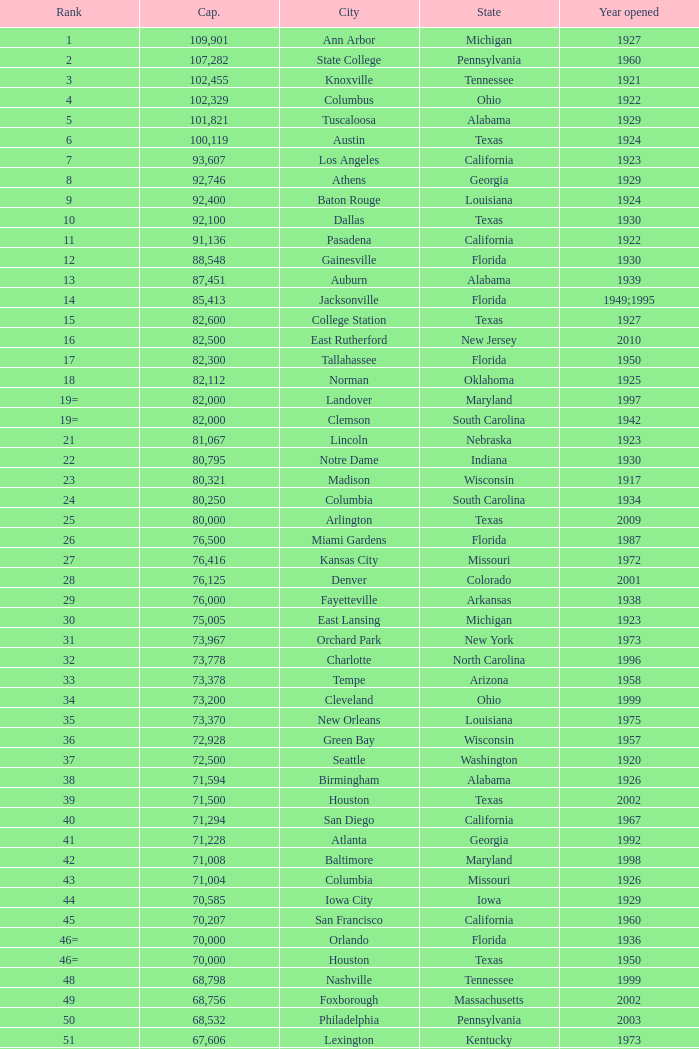Could you parse the entire table? {'header': ['Rank', 'Cap.', 'City', 'State', 'Year opened'], 'rows': [['1', '109,901', 'Ann Arbor', 'Michigan', '1927'], ['2', '107,282', 'State College', 'Pennsylvania', '1960'], ['3', '102,455', 'Knoxville', 'Tennessee', '1921'], ['4', '102,329', 'Columbus', 'Ohio', '1922'], ['5', '101,821', 'Tuscaloosa', 'Alabama', '1929'], ['6', '100,119', 'Austin', 'Texas', '1924'], ['7', '93,607', 'Los Angeles', 'California', '1923'], ['8', '92,746', 'Athens', 'Georgia', '1929'], ['9', '92,400', 'Baton Rouge', 'Louisiana', '1924'], ['10', '92,100', 'Dallas', 'Texas', '1930'], ['11', '91,136', 'Pasadena', 'California', '1922'], ['12', '88,548', 'Gainesville', 'Florida', '1930'], ['13', '87,451', 'Auburn', 'Alabama', '1939'], ['14', '85,413', 'Jacksonville', 'Florida', '1949;1995'], ['15', '82,600', 'College Station', 'Texas', '1927'], ['16', '82,500', 'East Rutherford', 'New Jersey', '2010'], ['17', '82,300', 'Tallahassee', 'Florida', '1950'], ['18', '82,112', 'Norman', 'Oklahoma', '1925'], ['19=', '82,000', 'Landover', 'Maryland', '1997'], ['19=', '82,000', 'Clemson', 'South Carolina', '1942'], ['21', '81,067', 'Lincoln', 'Nebraska', '1923'], ['22', '80,795', 'Notre Dame', 'Indiana', '1930'], ['23', '80,321', 'Madison', 'Wisconsin', '1917'], ['24', '80,250', 'Columbia', 'South Carolina', '1934'], ['25', '80,000', 'Arlington', 'Texas', '2009'], ['26', '76,500', 'Miami Gardens', 'Florida', '1987'], ['27', '76,416', 'Kansas City', 'Missouri', '1972'], ['28', '76,125', 'Denver', 'Colorado', '2001'], ['29', '76,000', 'Fayetteville', 'Arkansas', '1938'], ['30', '75,005', 'East Lansing', 'Michigan', '1923'], ['31', '73,967', 'Orchard Park', 'New York', '1973'], ['32', '73,778', 'Charlotte', 'North Carolina', '1996'], ['33', '73,378', 'Tempe', 'Arizona', '1958'], ['34', '73,200', 'Cleveland', 'Ohio', '1999'], ['35', '73,370', 'New Orleans', 'Louisiana', '1975'], ['36', '72,928', 'Green Bay', 'Wisconsin', '1957'], ['37', '72,500', 'Seattle', 'Washington', '1920'], ['38', '71,594', 'Birmingham', 'Alabama', '1926'], ['39', '71,500', 'Houston', 'Texas', '2002'], ['40', '71,294', 'San Diego', 'California', '1967'], ['41', '71,228', 'Atlanta', 'Georgia', '1992'], ['42', '71,008', 'Baltimore', 'Maryland', '1998'], ['43', '71,004', 'Columbia', 'Missouri', '1926'], ['44', '70,585', 'Iowa City', 'Iowa', '1929'], ['45', '70,207', 'San Francisco', 'California', '1960'], ['46=', '70,000', 'Orlando', 'Florida', '1936'], ['46=', '70,000', 'Houston', 'Texas', '1950'], ['48', '68,798', 'Nashville', 'Tennessee', '1999'], ['49', '68,756', 'Foxborough', 'Massachusetts', '2002'], ['50', '68,532', 'Philadelphia', 'Pennsylvania', '2003'], ['51', '67,606', 'Lexington', 'Kentucky', '1973'], ['52', '67,000', 'Seattle', 'Washington', '2002'], ['53', '66,965', 'St. Louis', 'Missouri', '1995'], ['54', '66,233', 'Blacksburg', 'Virginia', '1965'], ['55', '65,857', 'Tampa', 'Florida', '1998'], ['56', '65,790', 'Cincinnati', 'Ohio', '2000'], ['57', '65,050', 'Pittsburgh', 'Pennsylvania', '2001'], ['58=', '65,000', 'San Antonio', 'Texas', '1993'], ['58=', '65,000', 'Detroit', 'Michigan', '2002'], ['60', '64,269', 'New Haven', 'Connecticut', '1914'], ['61', '64,111', 'Minneapolis', 'Minnesota', '1982'], ['62', '64,045', 'Provo', 'Utah', '1964'], ['63', '63,400', 'Glendale', 'Arizona', '2006'], ['64', '63,026', 'Oakland', 'California', '1966'], ['65', '63,000', 'Indianapolis', 'Indiana', '2008'], ['65', '63.000', 'Chapel Hill', 'North Carolina', '1926'], ['66', '62,872', 'Champaign', 'Illinois', '1923'], ['67', '62,717', 'Berkeley', 'California', '1923'], ['68', '61,500', 'Chicago', 'Illinois', '1924;2003'], ['69', '62,500', 'West Lafayette', 'Indiana', '1924'], ['70', '62,380', 'Memphis', 'Tennessee', '1965'], ['71', '61,500', 'Charlottesville', 'Virginia', '1931'], ['72', '61,000', 'Lubbock', 'Texas', '1947'], ['73', '60,580', 'Oxford', 'Mississippi', '1915'], ['74', '60,540', 'Morgantown', 'West Virginia', '1980'], ['75', '60,492', 'Jackson', 'Mississippi', '1941'], ['76', '60,000', 'Stillwater', 'Oklahoma', '1920'], ['78', '57,803', 'Tucson', 'Arizona', '1928'], ['79', '57,583', 'Raleigh', 'North Carolina', '1966'], ['80', '56,692', 'Washington, D.C.', 'District of Columbia', '1961'], ['81=', '56,000', 'Los Angeles', 'California', '1962'], ['81=', '56,000', 'Louisville', 'Kentucky', '1998'], ['83', '55,082', 'Starkville', 'Mississippi', '1914'], ['84=', '55,000', 'Atlanta', 'Georgia', '1913'], ['84=', '55,000', 'Ames', 'Iowa', '1975'], ['86', '53,800', 'Eugene', 'Oregon', '1967'], ['87', '53,750', 'Boulder', 'Colorado', '1924'], ['88', '53,727', 'Little Rock', 'Arkansas', '1948'], ['89', '53,500', 'Bloomington', 'Indiana', '1960'], ['90', '52,593', 'Philadelphia', 'Pennsylvania', '1895'], ['91', '52,480', 'Colorado Springs', 'Colorado', '1962'], ['92', '52,454', 'Piscataway', 'New Jersey', '1994'], ['93', '52,200', 'Manhattan', 'Kansas', '1968'], ['94=', '51,500', 'College Park', 'Maryland', '1950'], ['94=', '51,500', 'El Paso', 'Texas', '1963'], ['96', '50,832', 'Shreveport', 'Louisiana', '1925'], ['97', '50,805', 'Minneapolis', 'Minnesota', '2009'], ['98', '50,445', 'Denver', 'Colorado', '1995'], ['99', '50,291', 'Bronx', 'New York', '2009'], ['100', '50,096', 'Atlanta', 'Georgia', '1996'], ['101', '50,071', 'Lawrence', 'Kansas', '1921'], ['102=', '50,000', 'Honolulu', 'Hawai ʻ i', '1975'], ['102=', '50,000', 'Greenville', 'North Carolina', '1963'], ['102=', '50,000', 'Waco', 'Texas', '1950'], ['102=', '50,000', 'Stanford', 'California', '1921;2006'], ['106', '49,262', 'Syracuse', 'New York', '1980'], ['107', '49,115', 'Arlington', 'Texas', '1994'], ['108', '49,033', 'Phoenix', 'Arizona', '1998'], ['109', '48,876', 'Baltimore', 'Maryland', '1992'], ['110', '47,130', 'Evanston', 'Illinois', '1996'], ['111', '47,116', 'Seattle', 'Washington', '1999'], ['112', '46,861', 'St. Louis', 'Missouri', '2006'], ['113', '45,674', 'Corvallis', 'Oregon', '1953'], ['114', '45,634', 'Salt Lake City', 'Utah', '1998'], ['115', '45,301', 'Orlando', 'Florida', '2007'], ['116', '45,050', 'Anaheim', 'California', '1966'], ['117', '44,500', 'Chestnut Hill', 'Massachusetts', '1957'], ['118', '44,008', 'Fort Worth', 'Texas', '1930'], ['119', '43,647', 'Philadelphia', 'Pennsylvania', '2004'], ['120', '43,545', 'Cleveland', 'Ohio', '1994'], ['121', '42,445', 'San Diego', 'California', '2004'], ['122', '42,059', 'Cincinnati', 'Ohio', '2003'], ['123', '41,900', 'Milwaukee', 'Wisconsin', '2001'], ['124', '41,888', 'Washington, D.C.', 'District of Columbia', '2008'], ['125', '41,800', 'Flushing, New York', 'New York', '2009'], ['126', '41,782', 'Detroit', 'Michigan', '2000'], ['127', '41,503', 'San Francisco', 'California', '2000'], ['128', '41,160', 'Chicago', 'Illinois', '1914'], ['129', '41,031', 'Fresno', 'California', '1980'], ['130', '40,950', 'Houston', 'Texas', '2000'], ['131', '40,646', 'Mobile', 'Alabama', '1948'], ['132', '40,615', 'Chicago', 'Illinois', '1991'], ['133', '40,094', 'Albuquerque', 'New Mexico', '1960'], ['134=', '40,000', 'South Williamsport', 'Pennsylvania', '1959'], ['134=', '40,000', 'East Hartford', 'Connecticut', '2003'], ['134=', '40,000', 'West Point', 'New York', '1924'], ['137', '39,790', 'Nashville', 'Tennessee', '1922'], ['138', '39,504', 'Minneapolis', 'Minnesota', '2010'], ['139', '39,000', 'Kansas City', 'Missouri', '1973'], ['140', '38,496', 'Pittsburgh', 'Pennsylvania', '2001'], ['141', '38,019', 'Huntington', 'West Virginia', '1991'], ['142', '37,402', 'Boston', 'Massachusetts', '1912'], ['143=', '37,000', 'Boise', 'Idaho', '1970'], ['143=', '37,000', 'Miami', 'Florida', '2012'], ['145', '36,973', 'St. Petersburg', 'Florida', '1990'], ['146', '36,800', 'Whitney', 'Nevada', '1971'], ['147', '36,000', 'Hattiesburg', 'Mississippi', '1932'], ['148', '35,117', 'Pullman', 'Washington', '1972'], ['149', '35,097', 'Cincinnati', 'Ohio', '1924'], ['150', '34,400', 'Fort Collins', 'Colorado', '1968'], ['151', '34,000', 'Annapolis', 'Maryland', '1959'], ['152', '33,941', 'Durham', 'North Carolina', '1929'], ['153', '32,580', 'Laramie', 'Wyoming', '1950'], ['154=', '32,000', 'University Park', 'Texas', '2000'], ['154=', '32,000', 'Houston', 'Texas', '1942'], ['156', '31,500', 'Winston-Salem', 'North Carolina', '1968'], ['157=', '31,000', 'Lafayette', 'Louisiana', '1971'], ['157=', '31,000', 'Akron', 'Ohio', '1940'], ['157=', '31,000', 'DeKalb', 'Illinois', '1965'], ['160', '30,964', 'Jonesboro', 'Arkansas', '1974'], ['161', '30,850', 'Denton', 'Texas', '2011'], ['162', '30,600', 'Ruston', 'Louisiana', '1960'], ['163', '30,456', 'San Jose', 'California', '1933'], ['164', '30,427', 'Monroe', 'Louisiana', '1978'], ['165', '30,343', 'Las Cruces', 'New Mexico', '1978'], ['166', '30,323', 'Allston', 'Massachusetts', '1903'], ['167', '30,295', 'Mount Pleasant', 'Michigan', '1972'], ['168=', '30,200', 'Ypsilanti', 'Michigan', '1969'], ['168=', '30,200', 'Kalamazoo', 'Michigan', '1939'], ['168=', '30,000', 'Boca Raton', 'Florida', '2011'], ['168=', '30,000', 'San Marcos', 'Texas', '1981'], ['168=', '30,000', 'Tulsa', 'Oklahoma', '1930'], ['168=', '30,000', 'Akron', 'Ohio', '2009'], ['168=', '30,000', 'Troy', 'Alabama', '1950'], ['168=', '30,000', 'Norfolk', 'Virginia', '1997'], ['176', '29,993', 'Reno', 'Nevada', '1966'], ['177', '29,013', 'Amherst', 'New York', '1993'], ['178', '29,000', 'Baton Rouge', 'Louisiana', '1928'], ['179', '28,646', 'Spokane', 'Washington', '1950'], ['180', '27,800', 'Princeton', 'New Jersey', '1998'], ['181', '27,000', 'Carson', 'California', '2003'], ['182', '26,248', 'Toledo', 'Ohio', '1937'], ['183', '25,600', 'Grambling', 'Louisiana', '1983'], ['184', '25,597', 'Ithaca', 'New York', '1915'], ['185', '25,500', 'Tallahassee', 'Florida', '1957'], ['186', '25,400', 'Muncie', 'Indiana', '1967'], ['187', '25,200', 'Missoula', 'Montana', '1986'], ['188', '25,189', 'Harrison', 'New Jersey', '2010'], ['189', '25,000', 'Kent', 'Ohio', '1969'], ['190', '24,877', 'Harrisonburg', 'Virginia', '1975'], ['191', '24,600', 'Montgomery', 'Alabama', '1922'], ['192', '24,286', 'Oxford', 'Ohio', '1983'], ['193=', '24,000', 'Omaha', 'Nebraska', '2011'], ['193=', '24,000', 'Athens', 'Ohio', '1929'], ['194', '23,724', 'Bowling Green', 'Ohio', '1966'], ['195', '23,500', 'Worcester', 'Massachusetts', '1924'], ['196', '22,500', 'Lorman', 'Mississippi', '1992'], ['197=', '22,000', 'Houston', 'Texas', '2012'], ['197=', '22,000', 'Newark', 'Delaware', '1952'], ['197=', '22,000', 'Bowling Green', 'Kentucky', '1968'], ['197=', '22,000', 'Orangeburg', 'South Carolina', '1955'], ['201', '21,650', 'Boone', 'North Carolina', '1962'], ['202', '21,500', 'Greensboro', 'North Carolina', '1981'], ['203', '21,650', 'Sacramento', 'California', '1969'], ['204=', '21,000', 'Charleston', 'South Carolina', '1946'], ['204=', '21,000', 'Huntsville', 'Alabama', '1996'], ['204=', '21,000', 'Chicago', 'Illinois', '1994'], ['207', '20,668', 'Chattanooga', 'Tennessee', '1997'], ['208', '20,630', 'Youngstown', 'Ohio', '1982'], ['209', '20,500', 'Frisco', 'Texas', '2005'], ['210', '20,455', 'Columbus', 'Ohio', '1999'], ['211', '20,450', 'Fort Lauderdale', 'Florida', '1959'], ['212', '20,438', 'Portland', 'Oregon', '1926'], ['213', '20,311', 'Sacramento, California', 'California', '1928'], ['214', '20,066', 'Detroit, Michigan', 'Michigan', '1979'], ['215', '20,008', 'Sandy', 'Utah', '2008'], ['216=', '20,000', 'Providence', 'Rhode Island', '1925'], ['216=', '20,000', 'Miami', 'Florida', '1995'], ['216=', '20,000', 'Richmond', 'Kentucky', '1969'], ['216=', '20,000', 'Mesquite', 'Texas', '1977'], ['216=', '20,000', 'Canyon', 'Texas', '1959'], ['216=', '20,000', 'Bridgeview', 'Illinois', '2006']]} What is the rank for the year opened in 1959 in Pennsylvania? 134=. 